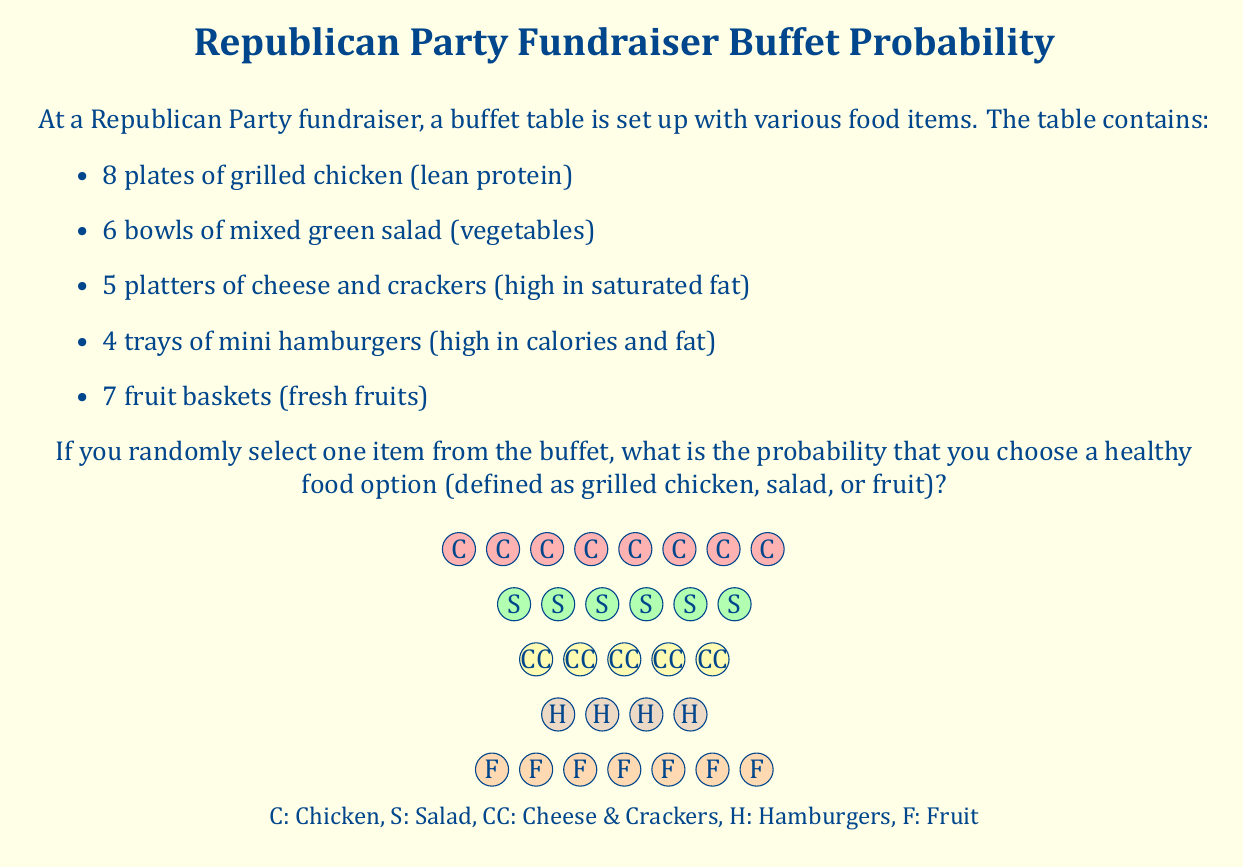Solve this math problem. Let's approach this step-by-step:

1) First, we need to identify the total number of items and the number of healthy items:

   Total items = 8 + 6 + 5 + 4 + 7 = 30

   Healthy items (chicken, salad, fruit) = 8 + 6 + 7 = 21

2) The probability of selecting a healthy item is the number of favorable outcomes divided by the total number of possible outcomes:

   $$P(\text{healthy}) = \frac{\text{number of healthy items}}{\text{total number of items}}$$

3) Substituting our values:

   $$P(\text{healthy}) = \frac{21}{30}$$

4) This fraction can be reduced:

   $$P(\text{healthy}) = \frac{7}{10} = 0.7$$

5) To express this as a percentage:

   $$P(\text{healthy}) = 0.7 \times 100\% = 70\%$$

Therefore, there is a 70% chance of selecting a healthy food item from the buffet.

This aligns with the Republican party member's strong belief in dietary health, as the majority of the options provided are healthy choices.
Answer: $\frac{7}{10}$ or 0.7 or 70% 